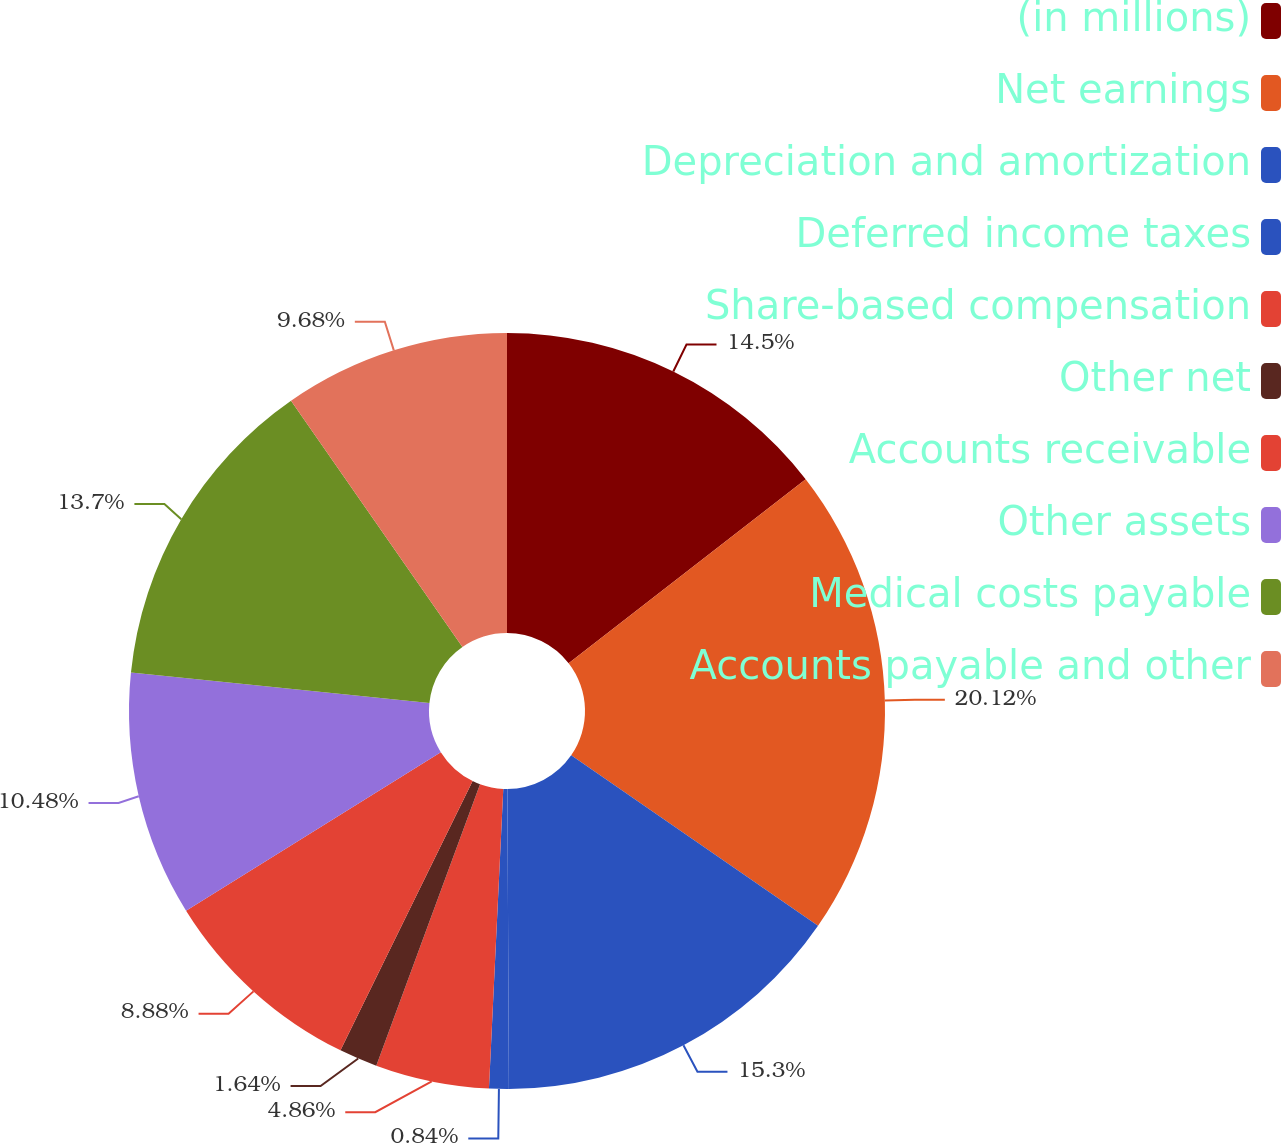<chart> <loc_0><loc_0><loc_500><loc_500><pie_chart><fcel>(in millions)<fcel>Net earnings<fcel>Depreciation and amortization<fcel>Deferred income taxes<fcel>Share-based compensation<fcel>Other net<fcel>Accounts receivable<fcel>Other assets<fcel>Medical costs payable<fcel>Accounts payable and other<nl><fcel>14.5%<fcel>20.12%<fcel>15.3%<fcel>0.84%<fcel>4.86%<fcel>1.64%<fcel>8.88%<fcel>10.48%<fcel>13.7%<fcel>9.68%<nl></chart> 